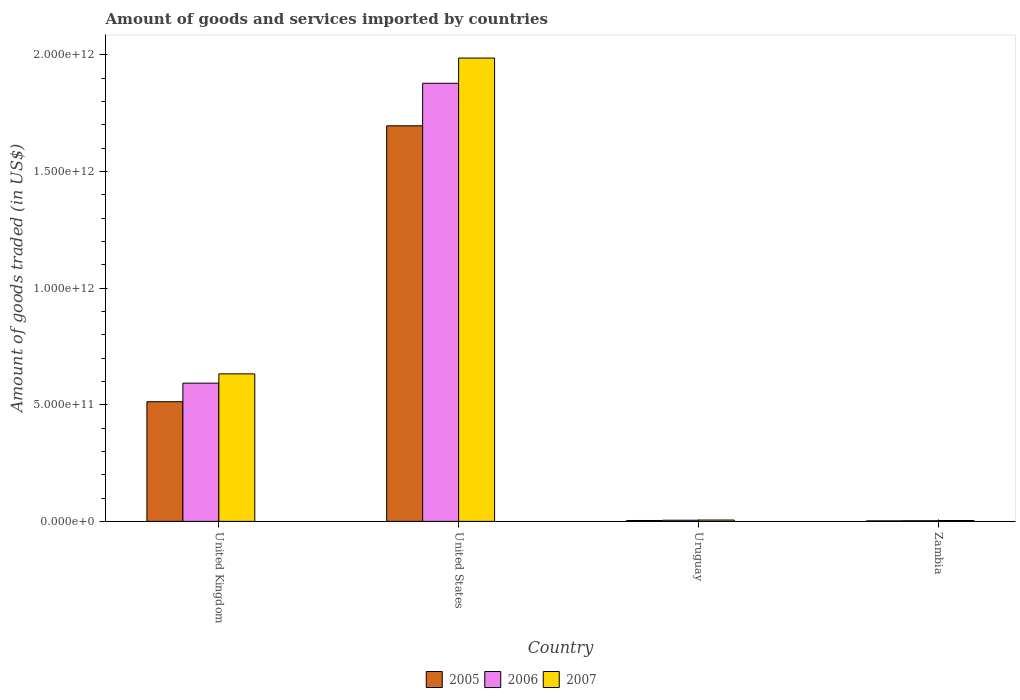How many different coloured bars are there?
Ensure brevity in your answer.  3. How many bars are there on the 1st tick from the left?
Provide a succinct answer. 3. How many bars are there on the 1st tick from the right?
Offer a very short reply. 3. What is the label of the 3rd group of bars from the left?
Your response must be concise. Uruguay. What is the total amount of goods and services imported in 2005 in Zambia?
Your answer should be compact. 2.16e+09. Across all countries, what is the maximum total amount of goods and services imported in 2005?
Your response must be concise. 1.70e+12. Across all countries, what is the minimum total amount of goods and services imported in 2007?
Ensure brevity in your answer.  3.61e+09. In which country was the total amount of goods and services imported in 2006 maximum?
Your answer should be compact. United States. In which country was the total amount of goods and services imported in 2005 minimum?
Provide a short and direct response. Zambia. What is the total total amount of goods and services imported in 2005 in the graph?
Offer a terse response. 2.21e+12. What is the difference between the total amount of goods and services imported in 2005 in United States and that in Uruguay?
Your answer should be very brief. 1.69e+12. What is the difference between the total amount of goods and services imported in 2005 in Zambia and the total amount of goods and services imported in 2006 in United States?
Provide a short and direct response. -1.88e+12. What is the average total amount of goods and services imported in 2007 per country?
Offer a terse response. 6.57e+11. What is the difference between the total amount of goods and services imported of/in 2005 and total amount of goods and services imported of/in 2006 in Zambia?
Provide a short and direct response. -4.75e+08. What is the ratio of the total amount of goods and services imported in 2007 in United States to that in Uruguay?
Ensure brevity in your answer.  351.85. Is the difference between the total amount of goods and services imported in 2005 in United States and Zambia greater than the difference between the total amount of goods and services imported in 2006 in United States and Zambia?
Ensure brevity in your answer.  No. What is the difference between the highest and the second highest total amount of goods and services imported in 2005?
Keep it short and to the point. 1.18e+12. What is the difference between the highest and the lowest total amount of goods and services imported in 2005?
Your answer should be compact. 1.69e+12. In how many countries, is the total amount of goods and services imported in 2005 greater than the average total amount of goods and services imported in 2005 taken over all countries?
Give a very brief answer. 1. Is the sum of the total amount of goods and services imported in 2005 in United Kingdom and United States greater than the maximum total amount of goods and services imported in 2006 across all countries?
Your answer should be very brief. Yes. What does the 1st bar from the left in United Kingdom represents?
Give a very brief answer. 2005. How many bars are there?
Offer a very short reply. 12. What is the difference between two consecutive major ticks on the Y-axis?
Ensure brevity in your answer.  5.00e+11. Does the graph contain any zero values?
Give a very brief answer. No. How many legend labels are there?
Make the answer very short. 3. How are the legend labels stacked?
Your response must be concise. Horizontal. What is the title of the graph?
Your response must be concise. Amount of goods and services imported by countries. What is the label or title of the Y-axis?
Ensure brevity in your answer.  Amount of goods traded (in US$). What is the Amount of goods traded (in US$) in 2005 in United Kingdom?
Ensure brevity in your answer.  5.13e+11. What is the Amount of goods traded (in US$) in 2006 in United Kingdom?
Give a very brief answer. 5.93e+11. What is the Amount of goods traded (in US$) in 2007 in United Kingdom?
Offer a terse response. 6.32e+11. What is the Amount of goods traded (in US$) of 2005 in United States?
Your response must be concise. 1.70e+12. What is the Amount of goods traded (in US$) of 2006 in United States?
Provide a succinct answer. 1.88e+12. What is the Amount of goods traded (in US$) of 2007 in United States?
Ensure brevity in your answer.  1.99e+12. What is the Amount of goods traded (in US$) of 2005 in Uruguay?
Provide a succinct answer. 3.75e+09. What is the Amount of goods traded (in US$) of 2006 in Uruguay?
Provide a short and direct response. 4.90e+09. What is the Amount of goods traded (in US$) of 2007 in Uruguay?
Provide a short and direct response. 5.65e+09. What is the Amount of goods traded (in US$) of 2005 in Zambia?
Your answer should be very brief. 2.16e+09. What is the Amount of goods traded (in US$) of 2006 in Zambia?
Give a very brief answer. 2.64e+09. What is the Amount of goods traded (in US$) of 2007 in Zambia?
Make the answer very short. 3.61e+09. Across all countries, what is the maximum Amount of goods traded (in US$) in 2005?
Give a very brief answer. 1.70e+12. Across all countries, what is the maximum Amount of goods traded (in US$) in 2006?
Provide a short and direct response. 1.88e+12. Across all countries, what is the maximum Amount of goods traded (in US$) in 2007?
Offer a very short reply. 1.99e+12. Across all countries, what is the minimum Amount of goods traded (in US$) in 2005?
Offer a terse response. 2.16e+09. Across all countries, what is the minimum Amount of goods traded (in US$) of 2006?
Keep it short and to the point. 2.64e+09. Across all countries, what is the minimum Amount of goods traded (in US$) of 2007?
Provide a succinct answer. 3.61e+09. What is the total Amount of goods traded (in US$) in 2005 in the graph?
Ensure brevity in your answer.  2.21e+12. What is the total Amount of goods traded (in US$) in 2006 in the graph?
Offer a terse response. 2.48e+12. What is the total Amount of goods traded (in US$) in 2007 in the graph?
Keep it short and to the point. 2.63e+12. What is the difference between the Amount of goods traded (in US$) in 2005 in United Kingdom and that in United States?
Keep it short and to the point. -1.18e+12. What is the difference between the Amount of goods traded (in US$) of 2006 in United Kingdom and that in United States?
Your answer should be compact. -1.29e+12. What is the difference between the Amount of goods traded (in US$) of 2007 in United Kingdom and that in United States?
Your response must be concise. -1.35e+12. What is the difference between the Amount of goods traded (in US$) in 2005 in United Kingdom and that in Uruguay?
Offer a very short reply. 5.09e+11. What is the difference between the Amount of goods traded (in US$) in 2006 in United Kingdom and that in Uruguay?
Keep it short and to the point. 5.88e+11. What is the difference between the Amount of goods traded (in US$) in 2007 in United Kingdom and that in Uruguay?
Your answer should be very brief. 6.27e+11. What is the difference between the Amount of goods traded (in US$) of 2005 in United Kingdom and that in Zambia?
Give a very brief answer. 5.11e+11. What is the difference between the Amount of goods traded (in US$) of 2006 in United Kingdom and that in Zambia?
Offer a very short reply. 5.90e+11. What is the difference between the Amount of goods traded (in US$) in 2007 in United Kingdom and that in Zambia?
Make the answer very short. 6.29e+11. What is the difference between the Amount of goods traded (in US$) of 2005 in United States and that in Uruguay?
Give a very brief answer. 1.69e+12. What is the difference between the Amount of goods traded (in US$) of 2006 in United States and that in Uruguay?
Your response must be concise. 1.87e+12. What is the difference between the Amount of goods traded (in US$) of 2007 in United States and that in Uruguay?
Your response must be concise. 1.98e+12. What is the difference between the Amount of goods traded (in US$) of 2005 in United States and that in Zambia?
Your answer should be compact. 1.69e+12. What is the difference between the Amount of goods traded (in US$) in 2006 in United States and that in Zambia?
Offer a very short reply. 1.88e+12. What is the difference between the Amount of goods traded (in US$) in 2007 in United States and that in Zambia?
Offer a very short reply. 1.98e+12. What is the difference between the Amount of goods traded (in US$) in 2005 in Uruguay and that in Zambia?
Make the answer very short. 1.59e+09. What is the difference between the Amount of goods traded (in US$) of 2006 in Uruguay and that in Zambia?
Ensure brevity in your answer.  2.26e+09. What is the difference between the Amount of goods traded (in US$) of 2007 in Uruguay and that in Zambia?
Make the answer very short. 2.03e+09. What is the difference between the Amount of goods traded (in US$) of 2005 in United Kingdom and the Amount of goods traded (in US$) of 2006 in United States?
Your answer should be compact. -1.37e+12. What is the difference between the Amount of goods traded (in US$) of 2005 in United Kingdom and the Amount of goods traded (in US$) of 2007 in United States?
Your response must be concise. -1.47e+12. What is the difference between the Amount of goods traded (in US$) in 2006 in United Kingdom and the Amount of goods traded (in US$) in 2007 in United States?
Provide a short and direct response. -1.39e+12. What is the difference between the Amount of goods traded (in US$) in 2005 in United Kingdom and the Amount of goods traded (in US$) in 2006 in Uruguay?
Provide a short and direct response. 5.08e+11. What is the difference between the Amount of goods traded (in US$) in 2005 in United Kingdom and the Amount of goods traded (in US$) in 2007 in Uruguay?
Make the answer very short. 5.07e+11. What is the difference between the Amount of goods traded (in US$) of 2006 in United Kingdom and the Amount of goods traded (in US$) of 2007 in Uruguay?
Give a very brief answer. 5.87e+11. What is the difference between the Amount of goods traded (in US$) of 2005 in United Kingdom and the Amount of goods traded (in US$) of 2006 in Zambia?
Your response must be concise. 5.10e+11. What is the difference between the Amount of goods traded (in US$) in 2005 in United Kingdom and the Amount of goods traded (in US$) in 2007 in Zambia?
Provide a succinct answer. 5.09e+11. What is the difference between the Amount of goods traded (in US$) in 2006 in United Kingdom and the Amount of goods traded (in US$) in 2007 in Zambia?
Your answer should be very brief. 5.89e+11. What is the difference between the Amount of goods traded (in US$) of 2005 in United States and the Amount of goods traded (in US$) of 2006 in Uruguay?
Your answer should be compact. 1.69e+12. What is the difference between the Amount of goods traded (in US$) of 2005 in United States and the Amount of goods traded (in US$) of 2007 in Uruguay?
Give a very brief answer. 1.69e+12. What is the difference between the Amount of goods traded (in US$) of 2006 in United States and the Amount of goods traded (in US$) of 2007 in Uruguay?
Keep it short and to the point. 1.87e+12. What is the difference between the Amount of goods traded (in US$) in 2005 in United States and the Amount of goods traded (in US$) in 2006 in Zambia?
Your answer should be compact. 1.69e+12. What is the difference between the Amount of goods traded (in US$) of 2005 in United States and the Amount of goods traded (in US$) of 2007 in Zambia?
Your answer should be compact. 1.69e+12. What is the difference between the Amount of goods traded (in US$) in 2006 in United States and the Amount of goods traded (in US$) in 2007 in Zambia?
Your response must be concise. 1.87e+12. What is the difference between the Amount of goods traded (in US$) of 2005 in Uruguay and the Amount of goods traded (in US$) of 2006 in Zambia?
Offer a very short reply. 1.12e+09. What is the difference between the Amount of goods traded (in US$) in 2005 in Uruguay and the Amount of goods traded (in US$) in 2007 in Zambia?
Keep it short and to the point. 1.43e+08. What is the difference between the Amount of goods traded (in US$) of 2006 in Uruguay and the Amount of goods traded (in US$) of 2007 in Zambia?
Provide a succinct answer. 1.29e+09. What is the average Amount of goods traded (in US$) of 2005 per country?
Provide a short and direct response. 5.54e+11. What is the average Amount of goods traded (in US$) in 2006 per country?
Make the answer very short. 6.20e+11. What is the average Amount of goods traded (in US$) in 2007 per country?
Provide a succinct answer. 6.57e+11. What is the difference between the Amount of goods traded (in US$) in 2005 and Amount of goods traded (in US$) in 2006 in United Kingdom?
Your answer should be compact. -7.96e+1. What is the difference between the Amount of goods traded (in US$) in 2005 and Amount of goods traded (in US$) in 2007 in United Kingdom?
Keep it short and to the point. -1.19e+11. What is the difference between the Amount of goods traded (in US$) in 2006 and Amount of goods traded (in US$) in 2007 in United Kingdom?
Your response must be concise. -3.98e+1. What is the difference between the Amount of goods traded (in US$) of 2005 and Amount of goods traded (in US$) of 2006 in United States?
Your response must be concise. -1.82e+11. What is the difference between the Amount of goods traded (in US$) of 2005 and Amount of goods traded (in US$) of 2007 in United States?
Your answer should be very brief. -2.91e+11. What is the difference between the Amount of goods traded (in US$) in 2006 and Amount of goods traded (in US$) in 2007 in United States?
Your answer should be very brief. -1.08e+11. What is the difference between the Amount of goods traded (in US$) of 2005 and Amount of goods traded (in US$) of 2006 in Uruguay?
Provide a succinct answer. -1.15e+09. What is the difference between the Amount of goods traded (in US$) in 2005 and Amount of goods traded (in US$) in 2007 in Uruguay?
Provide a short and direct response. -1.89e+09. What is the difference between the Amount of goods traded (in US$) in 2006 and Amount of goods traded (in US$) in 2007 in Uruguay?
Your answer should be very brief. -7.47e+08. What is the difference between the Amount of goods traded (in US$) in 2005 and Amount of goods traded (in US$) in 2006 in Zambia?
Make the answer very short. -4.75e+08. What is the difference between the Amount of goods traded (in US$) in 2005 and Amount of goods traded (in US$) in 2007 in Zambia?
Offer a terse response. -1.45e+09. What is the difference between the Amount of goods traded (in US$) in 2006 and Amount of goods traded (in US$) in 2007 in Zambia?
Provide a short and direct response. -9.75e+08. What is the ratio of the Amount of goods traded (in US$) of 2005 in United Kingdom to that in United States?
Offer a terse response. 0.3. What is the ratio of the Amount of goods traded (in US$) in 2006 in United Kingdom to that in United States?
Your answer should be compact. 0.32. What is the ratio of the Amount of goods traded (in US$) in 2007 in United Kingdom to that in United States?
Your response must be concise. 0.32. What is the ratio of the Amount of goods traded (in US$) of 2005 in United Kingdom to that in Uruguay?
Offer a terse response. 136.68. What is the ratio of the Amount of goods traded (in US$) in 2006 in United Kingdom to that in Uruguay?
Keep it short and to the point. 120.97. What is the ratio of the Amount of goods traded (in US$) in 2007 in United Kingdom to that in Uruguay?
Ensure brevity in your answer.  112.01. What is the ratio of the Amount of goods traded (in US$) in 2005 in United Kingdom to that in Zambia?
Provide a short and direct response. 237.42. What is the ratio of the Amount of goods traded (in US$) of 2006 in United Kingdom to that in Zambia?
Your answer should be very brief. 224.82. What is the ratio of the Amount of goods traded (in US$) in 2007 in United Kingdom to that in Zambia?
Ensure brevity in your answer.  175.14. What is the ratio of the Amount of goods traded (in US$) of 2005 in United States to that in Uruguay?
Offer a very short reply. 451.83. What is the ratio of the Amount of goods traded (in US$) in 2006 in United States to that in Uruguay?
Provide a short and direct response. 383.42. What is the ratio of the Amount of goods traded (in US$) of 2007 in United States to that in Uruguay?
Offer a very short reply. 351.85. What is the ratio of the Amount of goods traded (in US$) in 2005 in United States to that in Zambia?
Your answer should be very brief. 784.83. What is the ratio of the Amount of goods traded (in US$) of 2006 in United States to that in Zambia?
Offer a very short reply. 712.57. What is the ratio of the Amount of goods traded (in US$) in 2007 in United States to that in Zambia?
Give a very brief answer. 550.15. What is the ratio of the Amount of goods traded (in US$) of 2005 in Uruguay to that in Zambia?
Give a very brief answer. 1.74. What is the ratio of the Amount of goods traded (in US$) in 2006 in Uruguay to that in Zambia?
Offer a terse response. 1.86. What is the ratio of the Amount of goods traded (in US$) of 2007 in Uruguay to that in Zambia?
Give a very brief answer. 1.56. What is the difference between the highest and the second highest Amount of goods traded (in US$) of 2005?
Your response must be concise. 1.18e+12. What is the difference between the highest and the second highest Amount of goods traded (in US$) of 2006?
Keep it short and to the point. 1.29e+12. What is the difference between the highest and the second highest Amount of goods traded (in US$) in 2007?
Your answer should be compact. 1.35e+12. What is the difference between the highest and the lowest Amount of goods traded (in US$) in 2005?
Keep it short and to the point. 1.69e+12. What is the difference between the highest and the lowest Amount of goods traded (in US$) of 2006?
Provide a succinct answer. 1.88e+12. What is the difference between the highest and the lowest Amount of goods traded (in US$) in 2007?
Your answer should be very brief. 1.98e+12. 